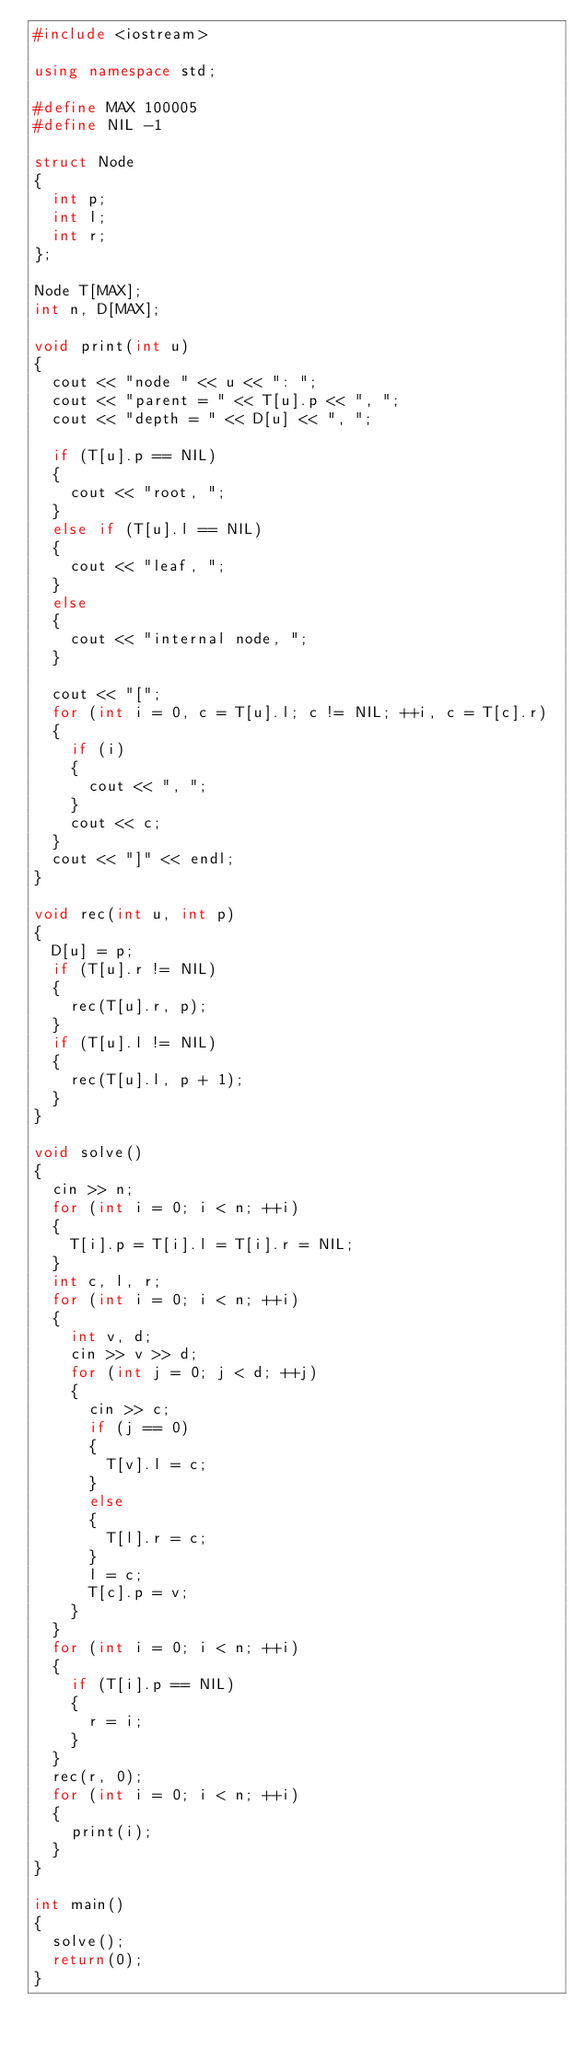<code> <loc_0><loc_0><loc_500><loc_500><_C++_>#include <iostream>

using namespace std;

#define MAX 100005
#define NIL -1

struct Node
{
	int p;
	int l;
	int r;
};

Node T[MAX];
int n, D[MAX];

void print(int u)
{
	cout << "node " << u << ": ";
	cout << "parent = " << T[u].p << ", ";
	cout << "depth = " << D[u] << ", ";

	if (T[u].p == NIL)
	{
		cout << "root, ";
	}
	else if (T[u].l == NIL)
	{
		cout << "leaf, ";
	}
	else
	{
		cout << "internal node, ";
	}

	cout << "[";
	for (int i = 0, c = T[u].l; c != NIL; ++i, c = T[c].r)
	{
		if (i)
		{
			cout << ", ";
		}
		cout << c;
	}
	cout << "]" << endl;
}

void rec(int u, int p)
{
	D[u] = p;
	if (T[u].r != NIL)
	{
		rec(T[u].r, p);
	}
	if (T[u].l != NIL)
	{
		rec(T[u].l, p + 1);
	}
}

void solve()
{
	cin >> n;
	for (int i = 0; i < n; ++i)
	{
		T[i].p = T[i].l = T[i].r = NIL;
	}
	int c, l, r;
	for (int i = 0; i < n; ++i)
	{
		int v, d;
		cin >> v >> d;
		for (int j = 0; j < d; ++j)
		{
			cin >> c;
			if (j == 0)
			{
				T[v].l = c;
			}
			else
			{
				T[l].r = c;
			}
			l = c;
			T[c].p = v;
		}
	}
	for (int i = 0; i < n; ++i)
	{
		if (T[i].p == NIL)
		{
			r = i;
		}
	}
	rec(r, 0);
	for (int i = 0; i < n; ++i)
	{
		print(i);
	}
}

int main()
{
	solve();
	return(0);
}

</code> 